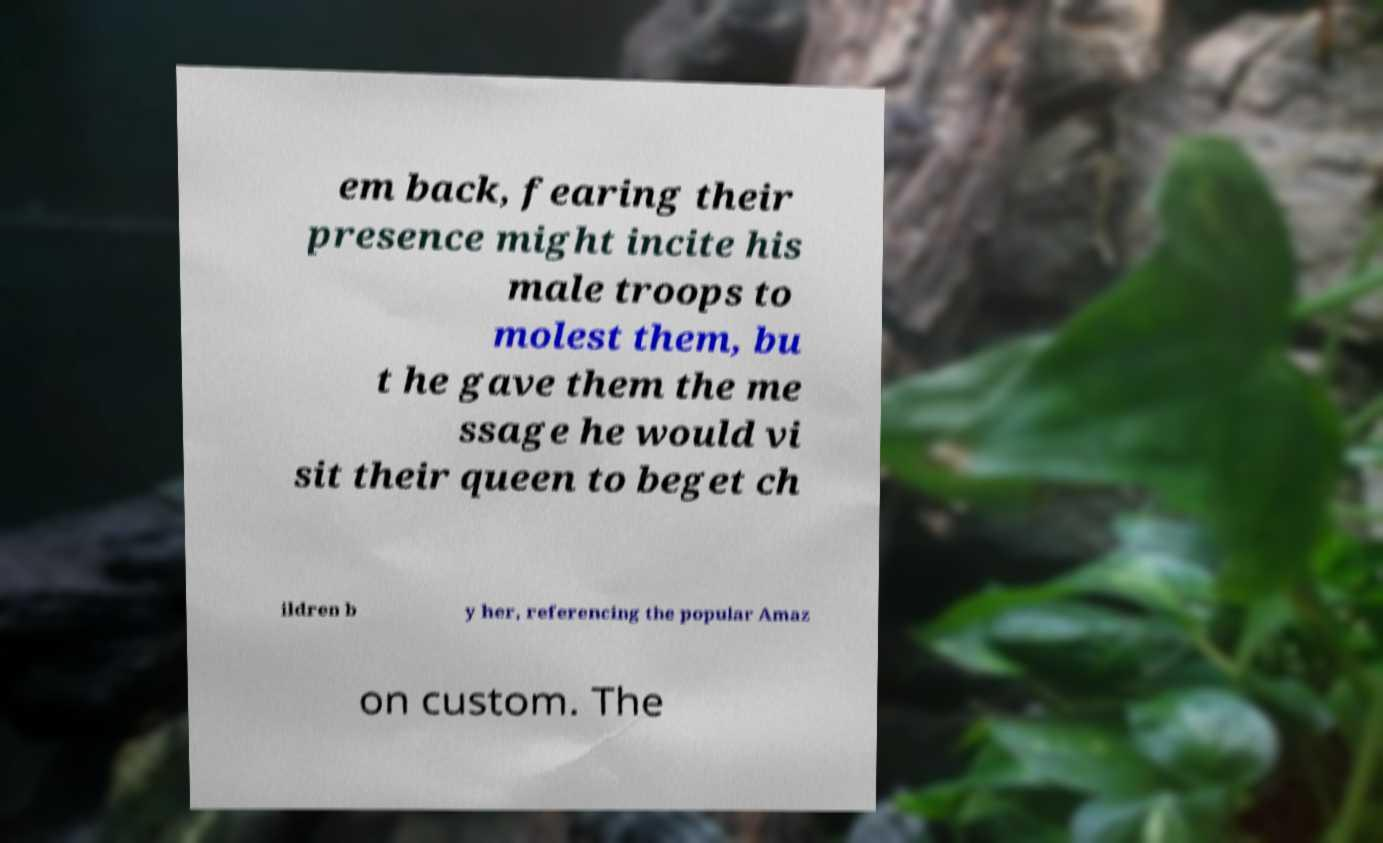Please read and relay the text visible in this image. What does it say? em back, fearing their presence might incite his male troops to molest them, bu t he gave them the me ssage he would vi sit their queen to beget ch ildren b y her, referencing the popular Amaz on custom. The 